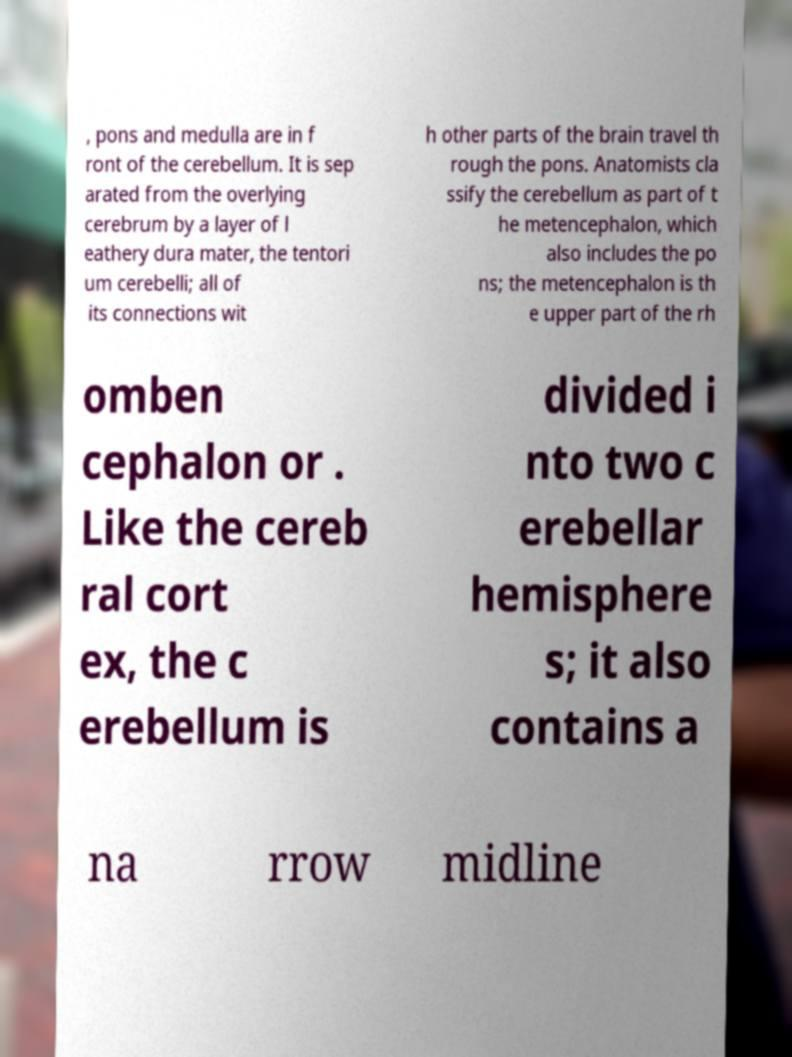I need the written content from this picture converted into text. Can you do that? , pons and medulla are in f ront of the cerebellum. It is sep arated from the overlying cerebrum by a layer of l eathery dura mater, the tentori um cerebelli; all of its connections wit h other parts of the brain travel th rough the pons. Anatomists cla ssify the cerebellum as part of t he metencephalon, which also includes the po ns; the metencephalon is th e upper part of the rh omben cephalon or . Like the cereb ral cort ex, the c erebellum is divided i nto two c erebellar hemisphere s; it also contains a na rrow midline 